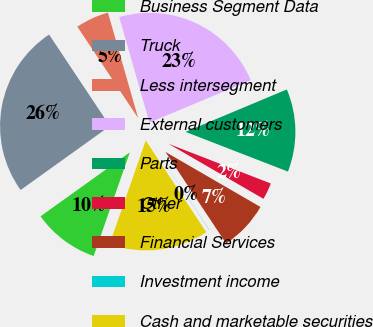Convert chart to OTSL. <chart><loc_0><loc_0><loc_500><loc_500><pie_chart><fcel>Business Segment Data<fcel>Truck<fcel>Less intersegment<fcel>External customers<fcel>Parts<fcel>Other<fcel>Financial Services<fcel>Investment income<fcel>Cash and marketable securities<nl><fcel>9.76%<fcel>25.56%<fcel>4.9%<fcel>23.13%<fcel>12.2%<fcel>2.47%<fcel>7.33%<fcel>0.03%<fcel>14.63%<nl></chart> 